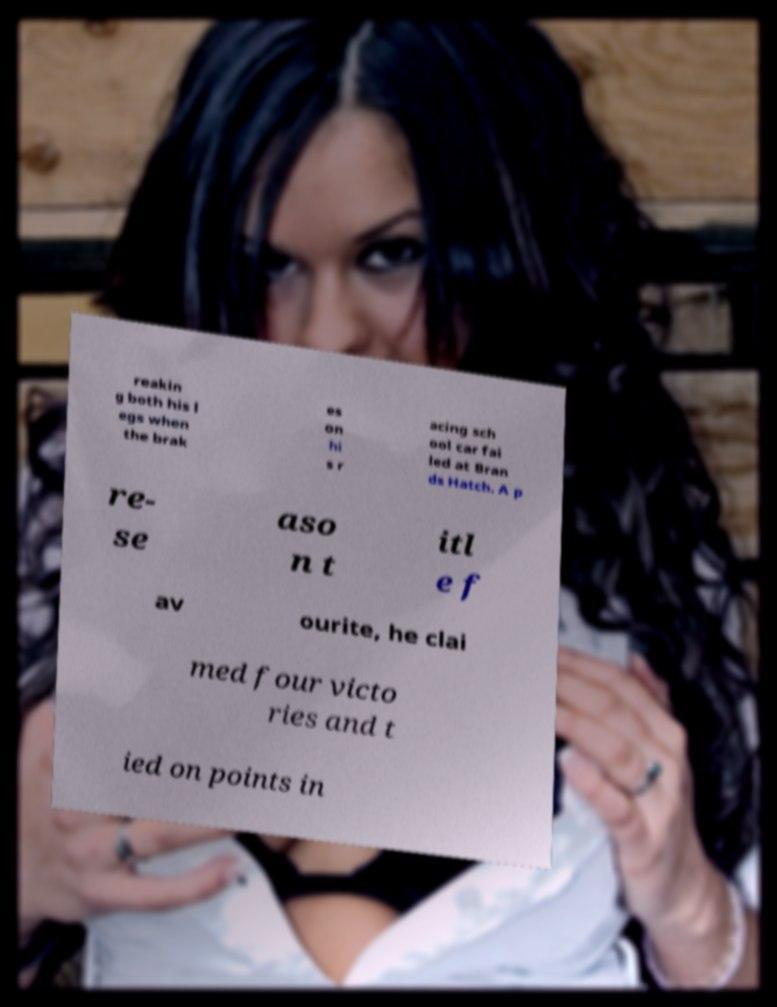Could you assist in decoding the text presented in this image and type it out clearly? reakin g both his l egs when the brak es on hi s r acing sch ool car fai led at Bran ds Hatch. A p re- se aso n t itl e f av ourite, he clai med four victo ries and t ied on points in 